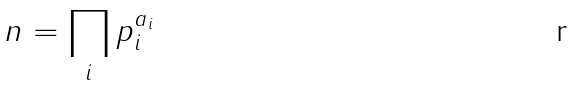<formula> <loc_0><loc_0><loc_500><loc_500>n = \prod _ { i } p _ { i } ^ { a _ { i } }</formula> 